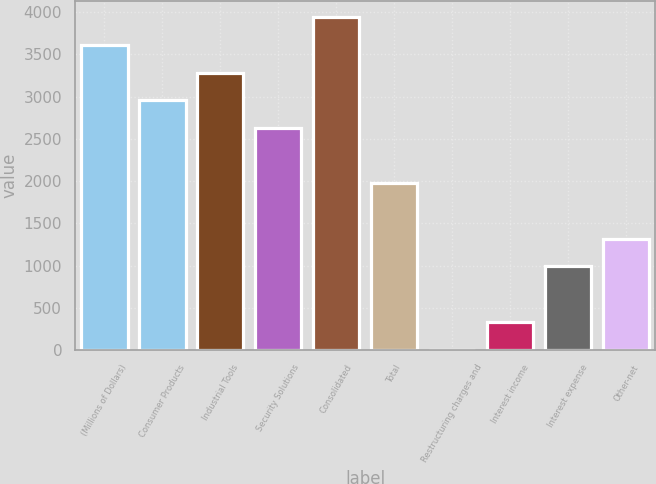<chart> <loc_0><loc_0><loc_500><loc_500><bar_chart><fcel>(Millions of Dollars)<fcel>Consumer Products<fcel>Industrial Tools<fcel>Security Solutions<fcel>Consolidated<fcel>Total<fcel>Restructuring charges and<fcel>Interest income<fcel>Interest expense<fcel>Other-net<nl><fcel>3613.37<fcel>2957.23<fcel>3285.3<fcel>2629.16<fcel>3941.44<fcel>1973.02<fcel>4.6<fcel>332.67<fcel>988.81<fcel>1316.88<nl></chart> 